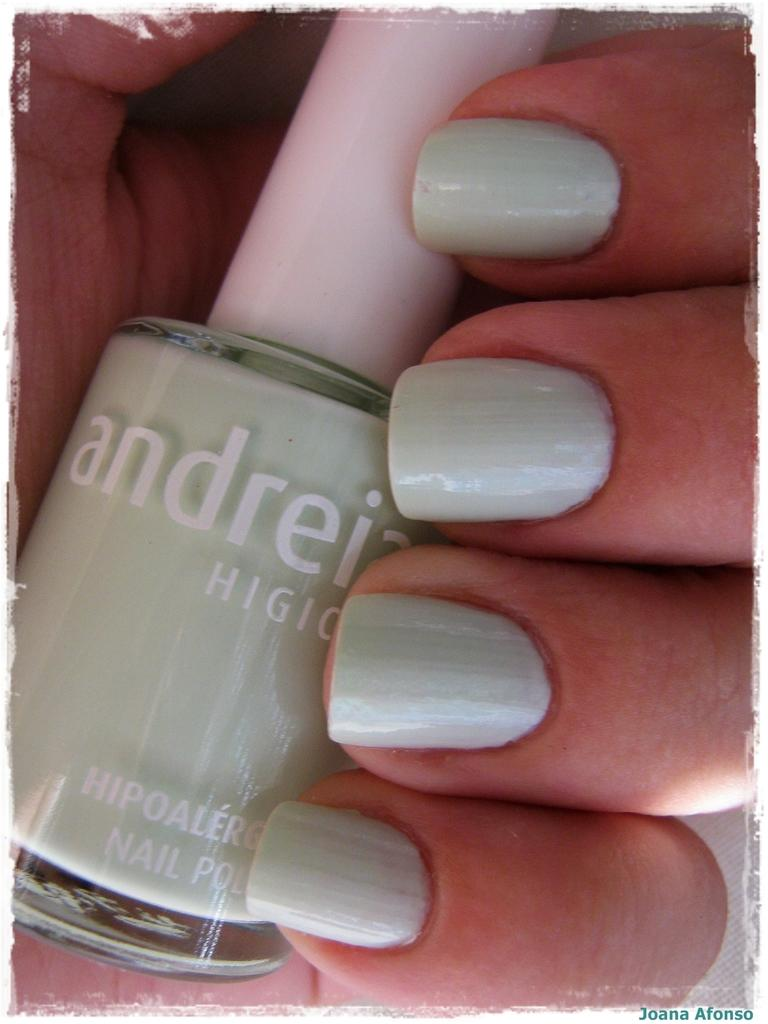<image>
Present a compact description of the photo's key features. A woman is holding a bottle is andreia nail color. 